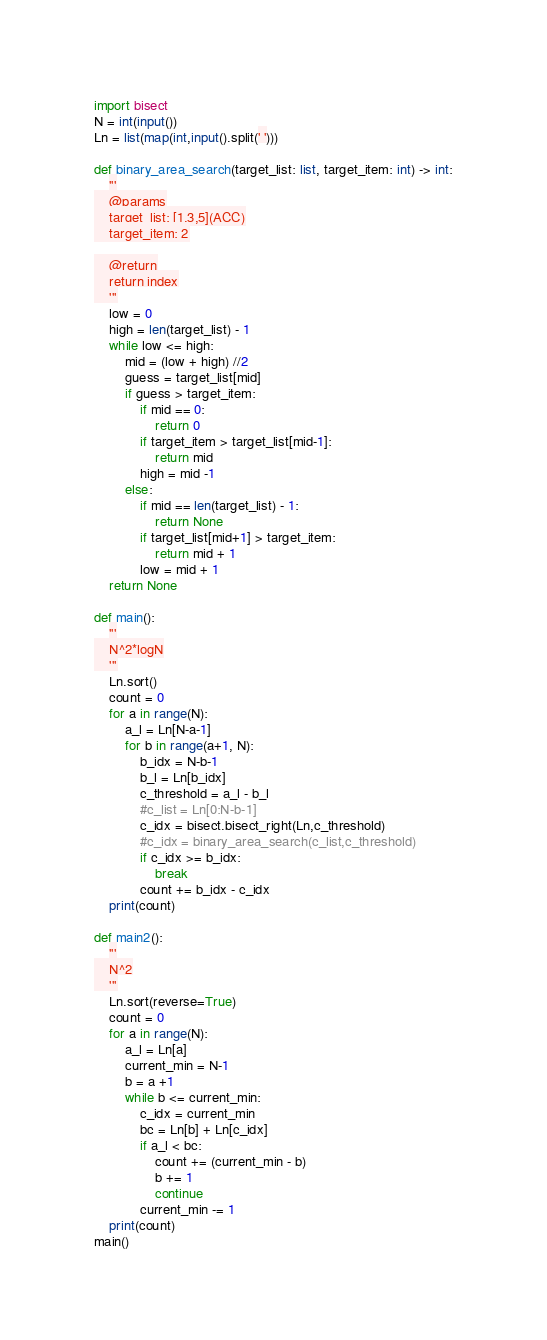<code> <loc_0><loc_0><loc_500><loc_500><_Python_>import bisect
N = int(input())
Ln = list(map(int,input().split(' ')))

def binary_area_search(target_list: list, target_item: int) -> int:
    '''
    @params
    target_list: [1,3,5](ACC)
    target_item: 2

    @return
    return index
    '''
    low = 0
    high = len(target_list) - 1
    while low <= high:
        mid = (low + high) //2
        guess = target_list[mid]
        if guess > target_item:
            if mid == 0:
                return 0
            if target_item > target_list[mid-1]:
                return mid 
            high = mid -1
        else:
            if mid == len(target_list) - 1:
                return None
            if target_list[mid+1] > target_item:
                return mid + 1 
            low = mid + 1
    return None

def main():
    '''
    N^2*logN
    '''
    Ln.sort()
    count = 0
    for a in range(N):
        a_l = Ln[N-a-1]
        for b in range(a+1, N):
            b_idx = N-b-1
            b_l = Ln[b_idx]
            c_threshold = a_l - b_l
            #c_list = Ln[0:N-b-1]
            c_idx = bisect.bisect_right(Ln,c_threshold)
            #c_idx = binary_area_search(c_list,c_threshold)
            if c_idx >= b_idx:
                break
            count += b_idx - c_idx
    print(count)

def main2():
    '''
    N^2
    '''
    Ln.sort(reverse=True)
    count = 0
    for a in range(N):
        a_l = Ln[a]
        current_min = N-1
        b = a +1
        while b <= current_min:
            c_idx = current_min
            bc = Ln[b] + Ln[c_idx]
            if a_l < bc:
                count += (current_min - b)
                b += 1
                continue
            current_min -= 1
    print(count)
main()</code> 